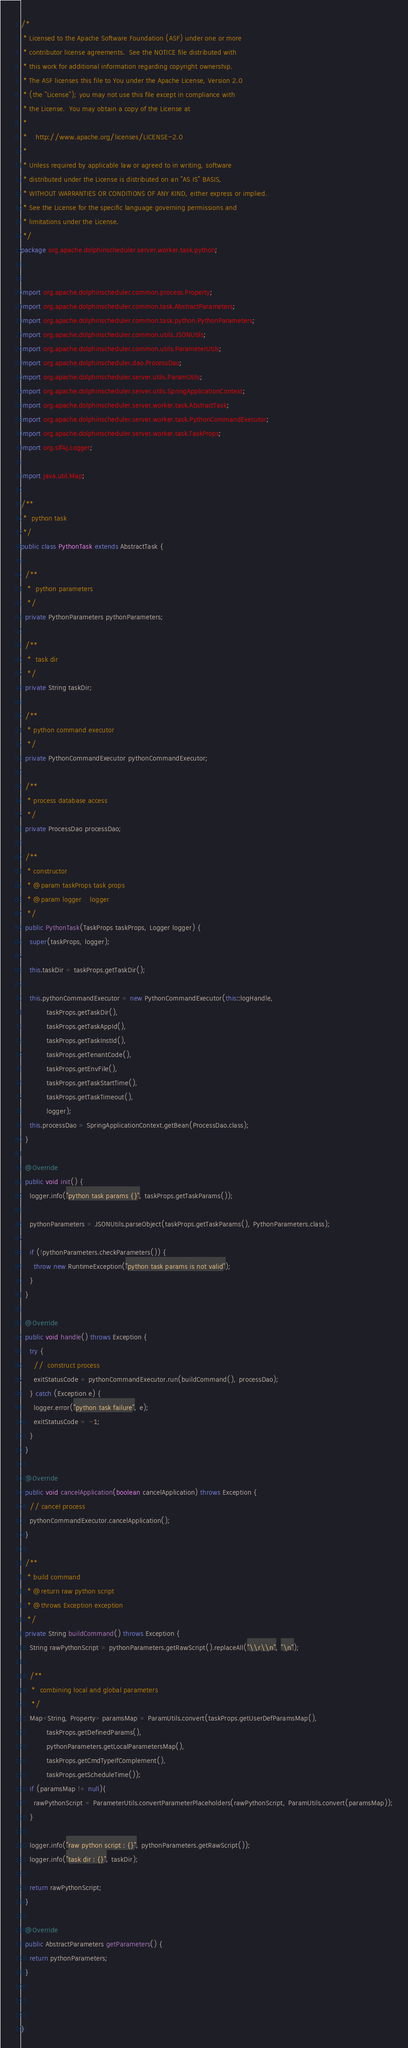<code> <loc_0><loc_0><loc_500><loc_500><_Java_>/*
 * Licensed to the Apache Software Foundation (ASF) under one or more
 * contributor license agreements.  See the NOTICE file distributed with
 * this work for additional information regarding copyright ownership.
 * The ASF licenses this file to You under the Apache License, Version 2.0
 * (the "License"); you may not use this file except in compliance with
 * the License.  You may obtain a copy of the License at
 *
 *    http://www.apache.org/licenses/LICENSE-2.0
 *
 * Unless required by applicable law or agreed to in writing, software
 * distributed under the License is distributed on an "AS IS" BASIS,
 * WITHOUT WARRANTIES OR CONDITIONS OF ANY KIND, either express or implied.
 * See the License for the specific language governing permissions and
 * limitations under the License.
 */
package org.apache.dolphinscheduler.server.worker.task.python;


import org.apache.dolphinscheduler.common.process.Property;
import org.apache.dolphinscheduler.common.task.AbstractParameters;
import org.apache.dolphinscheduler.common.task.python.PythonParameters;
import org.apache.dolphinscheduler.common.utils.JSONUtils;
import org.apache.dolphinscheduler.common.utils.ParameterUtils;
import org.apache.dolphinscheduler.dao.ProcessDao;
import org.apache.dolphinscheduler.server.utils.ParamUtils;
import org.apache.dolphinscheduler.server.utils.SpringApplicationContext;
import org.apache.dolphinscheduler.server.worker.task.AbstractTask;
import org.apache.dolphinscheduler.server.worker.task.PythonCommandExecutor;
import org.apache.dolphinscheduler.server.worker.task.TaskProps;
import org.slf4j.Logger;

import java.util.Map;

/**
 *  python task
 */
public class PythonTask extends AbstractTask {

  /**
   *  python parameters
   */
  private PythonParameters pythonParameters;

  /**
   *  task dir
   */
  private String taskDir;

  /**
   * python command executor
   */
  private PythonCommandExecutor pythonCommandExecutor;

  /**
   * process database access
   */
  private ProcessDao processDao;

  /**
   * constructor
   * @param taskProps task props
   * @param logger    logger
   */
  public PythonTask(TaskProps taskProps, Logger logger) {
    super(taskProps, logger);

    this.taskDir = taskProps.getTaskDir();

    this.pythonCommandExecutor = new PythonCommandExecutor(this::logHandle,
            taskProps.getTaskDir(),
            taskProps.getTaskAppId(),
            taskProps.getTaskInstId(),
            taskProps.getTenantCode(),
            taskProps.getEnvFile(),
            taskProps.getTaskStartTime(),
            taskProps.getTaskTimeout(),
            logger);
    this.processDao = SpringApplicationContext.getBean(ProcessDao.class);
  }

  @Override
  public void init() {
    logger.info("python task params {}", taskProps.getTaskParams());

    pythonParameters = JSONUtils.parseObject(taskProps.getTaskParams(), PythonParameters.class);

    if (!pythonParameters.checkParameters()) {
      throw new RuntimeException("python task params is not valid");
    }
  }

  @Override
  public void handle() throws Exception {
    try {
      //  construct process
      exitStatusCode = pythonCommandExecutor.run(buildCommand(), processDao);
    } catch (Exception e) {
      logger.error("python task failure", e);
      exitStatusCode = -1;
    }
  }

  @Override
  public void cancelApplication(boolean cancelApplication) throws Exception {
    // cancel process
    pythonCommandExecutor.cancelApplication();
  }

  /**
   * build command
   * @return raw python script
   * @throws Exception exception
   */
  private String buildCommand() throws Exception {
    String rawPythonScript = pythonParameters.getRawScript().replaceAll("\\r\\n", "\n");

    /**
     *  combining local and global parameters
     */
    Map<String, Property> paramsMap = ParamUtils.convert(taskProps.getUserDefParamsMap(),
            taskProps.getDefinedParams(),
            pythonParameters.getLocalParametersMap(),
            taskProps.getCmdTypeIfComplement(),
            taskProps.getScheduleTime());
    if (paramsMap != null){
      rawPythonScript = ParameterUtils.convertParameterPlaceholders(rawPythonScript, ParamUtils.convert(paramsMap));
    }

    logger.info("raw python script : {}", pythonParameters.getRawScript());
    logger.info("task dir : {}", taskDir);

    return rawPythonScript;
  }

  @Override
  public AbstractParameters getParameters() {
    return pythonParameters;
  }



}
</code> 